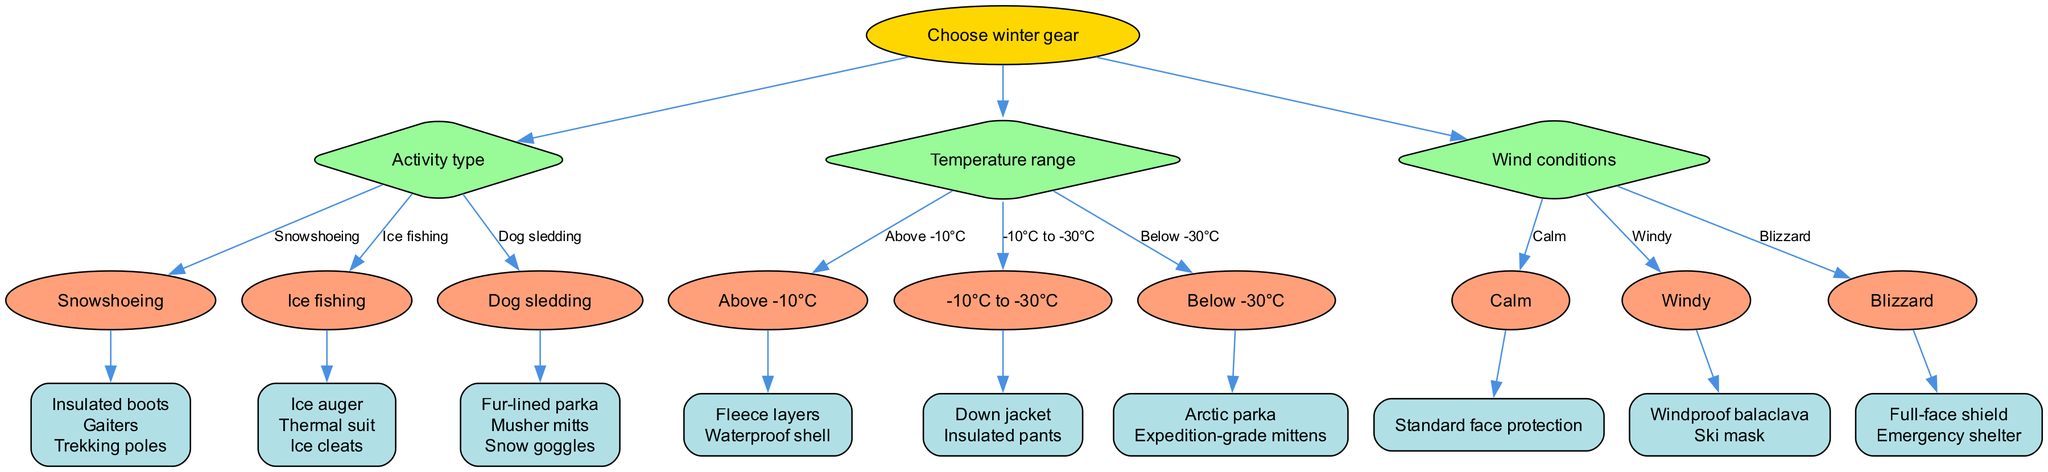What is the root of the decision tree? The root node in the decision tree represents the main decision point, which is "Choose winter gear." This is the starting point from which all branches and options flow.
Answer: Choose winter gear How many activity types are presented in the diagram? The diagram indicates three activity types: "Snowshoeing," "Ice fishing," and "Dog sledding." Counting these options gives us a total of three.
Answer: 3 What gear is recommended for dog sledding? For the activity "Dog sledding," the recommended gear includes a "Fur-lined parka," "Musher mitts," and "Snow goggles." This information is found in the corresponding options branch for dog sledding.
Answer: Fur-lined parka, Musher mitts, Snow goggles Which gear should be worn below -30°C? In the temperature range below -30°C, the recommended gear from the decision tree is an "Arctic parka" and "Expedition-grade mittens." These gear choices are listed under the appropriate temperature condition.
Answer: Arctic parka, Expedition-grade mittens What happens in windy conditions? In windy conditions, the diagram suggests wearing a "Windproof balaclava" and a "Ski mask." This is derived from the branch that specifies gear for various wind conditions.
Answer: Windproof balaclava, Ski mask What is the sequence for choosing gear based on temperature? To determine the gear based on temperature, you start at the root, move to the "Temperature range" node, and then select one of the three options based on current conditions. The final output will depend on whether temperatures are above -10°C, between -10°C to -30°C, or below -30°C.
Answer: Sequence through temperature range node What type of gear is best for blizzard conditions? In the event of blizzard conditions, the recommended gear includes a "Full-face shield" and "Emergency shelter," mentioned in the relevant wind condition branch.
Answer: Full-face shield, Emergency shelter Which type of gear do you need for snowshoeing? For the activity of "Snowshoeing," the diagram indicates that you should use "Insulated boots," "Gaiters," and "Trekking poles." This information comes from the respective options under the activity type.
Answer: Insulated boots, Gaiters, Trekking poles What type of face protection is needed for calm winds? When the wind condition is calm, the diagram specifies "Standard face protection" as the appropriate gear. This gear choice is made based on the calm conditions branch.
Answer: Standard face protection 